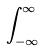<formula> <loc_0><loc_0><loc_500><loc_500>\int _ { - \infty } ^ { \infty }</formula> 